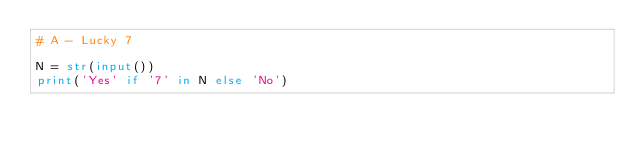Convert code to text. <code><loc_0><loc_0><loc_500><loc_500><_Python_># A - Lucky 7

N = str(input())
print('Yes' if '7' in N else 'No')</code> 